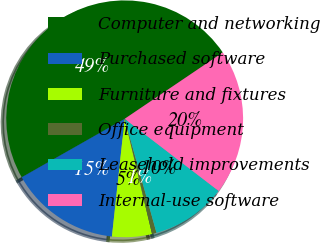Convert chart to OTSL. <chart><loc_0><loc_0><loc_500><loc_500><pie_chart><fcel>Computer and networking<fcel>Purchased software<fcel>Furniture and fixtures<fcel>Office equipment<fcel>Leasehold improvements<fcel>Internal-use software<nl><fcel>48.76%<fcel>15.06%<fcel>5.43%<fcel>0.62%<fcel>10.25%<fcel>19.88%<nl></chart> 